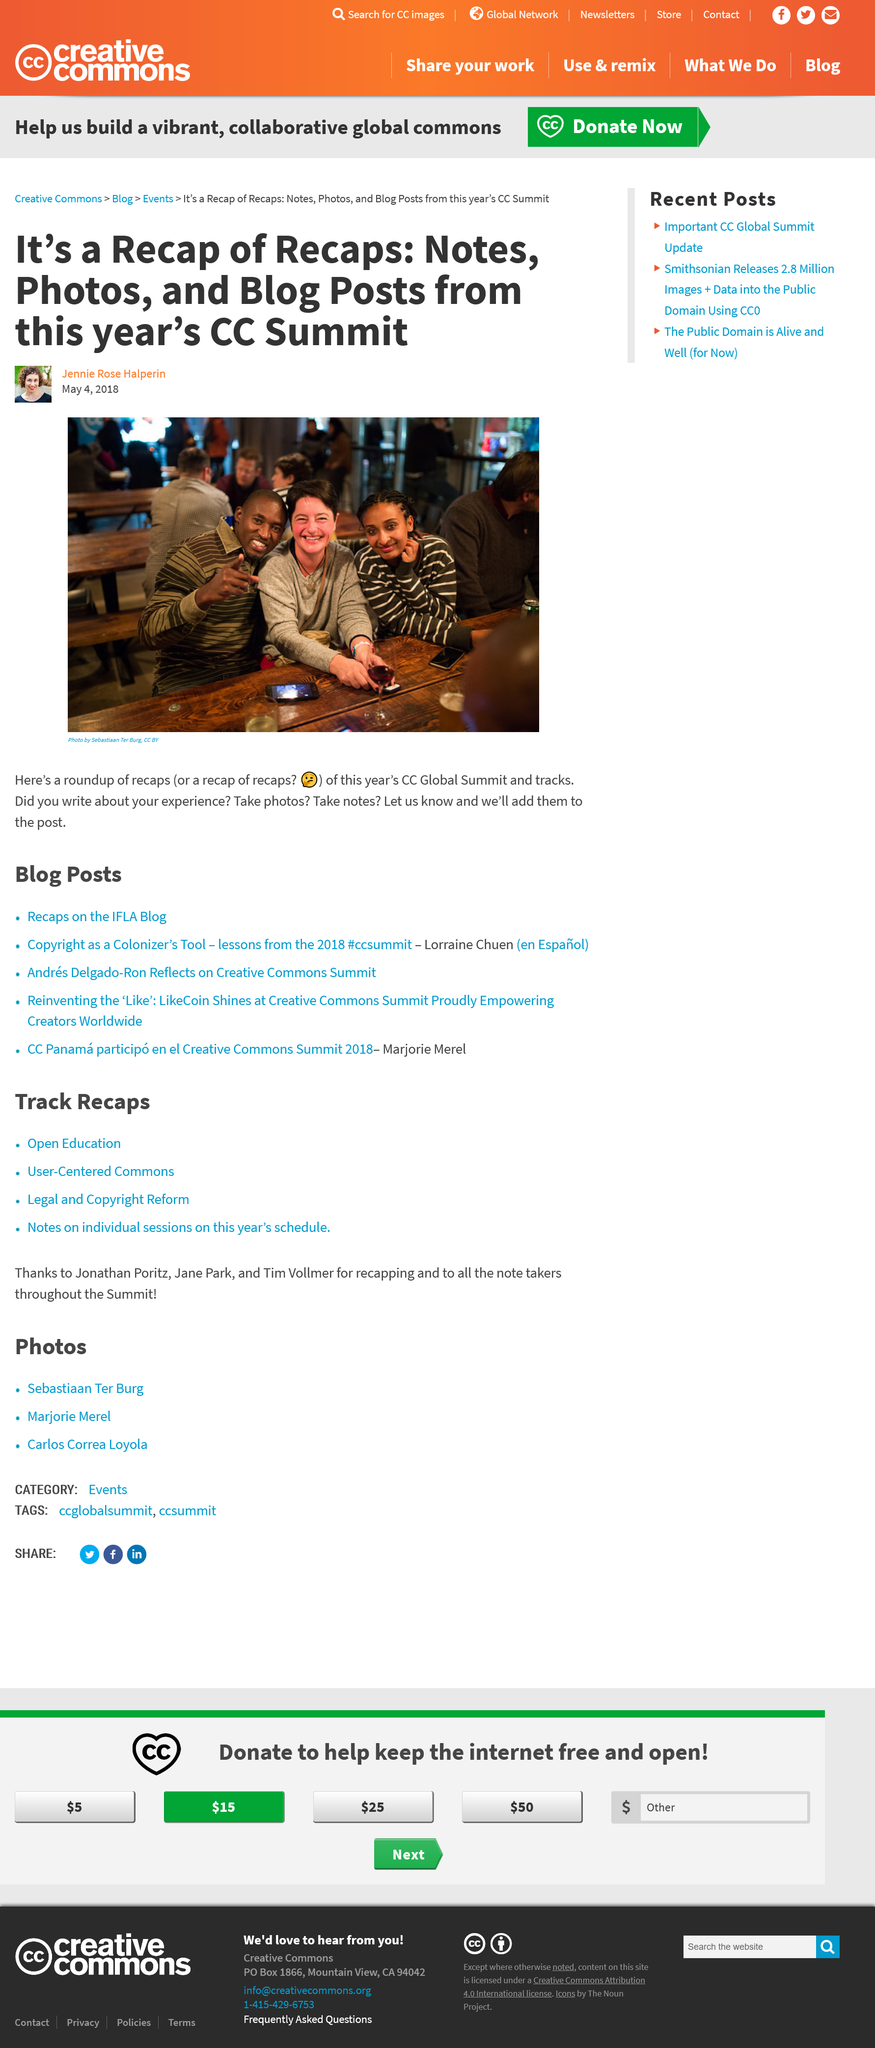Point out several critical features in this image. Notes, photos, and blog posts are included in the recap of recaps from the CC Global Summit. The recap of recaps from the CC Global Summit was published on May 4, 2018. It is requested that any additional information, such as photos, notes, or blog posts, related to the CC Global Summit be submitted to Jennie Rose Halperin. 